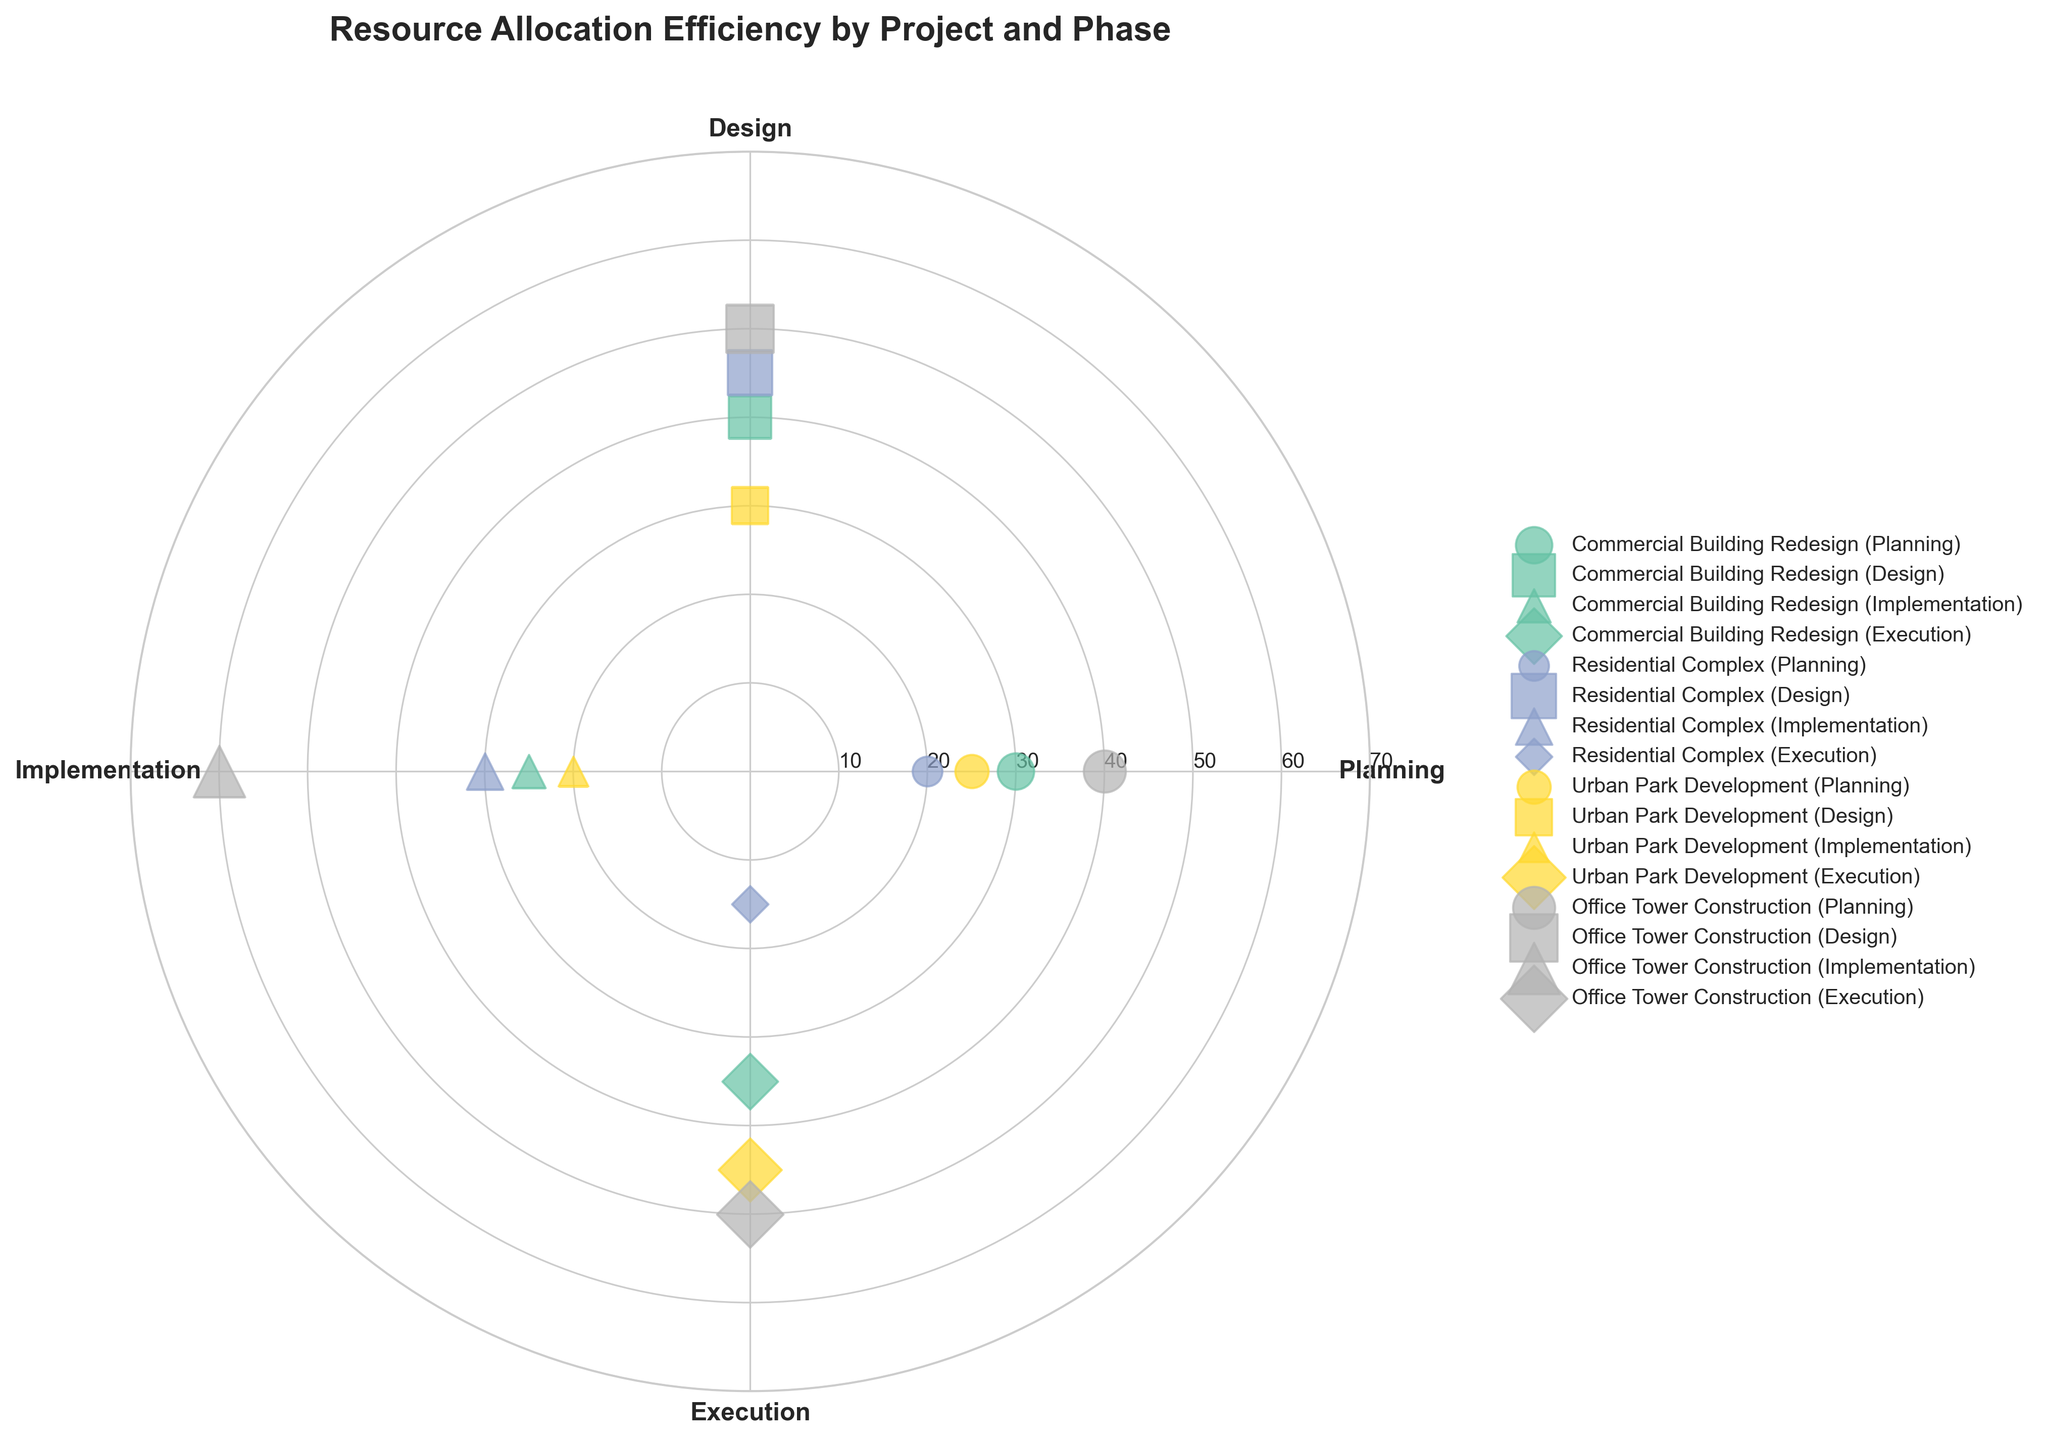what is the title of the figure? The title is located at the top of the figure and is in bold font.
Answer: Resource Allocation Efficiency by Project and Phase Which project has the highest man-hours allocated to the Planning phase? By looking at the points along the Planning axis (0 degrees), the project with the highest man-hours is marked and it corresponds to the highest radius value.
Answer: Office Tower Construction How many different phases are there in the chart? The phases are the labeled categories on the outer circle at the angles 0, 90, 180, and 270 degrees. Count these labels.
Answer: Four Which project has the smallest man-hours allocated to the Execution phase? By looking at the points along the Execution axis (270 degrees), the project with the smallest radius value is the one with the least man-hours.
Answer: Residential Complex What is the total man-hours allocated in the Design phase for all projects? Summing the values of the man-hours corresponding to points along the Design axis (90 degrees). These are 40 (Commercial Building Redesign), 45 (Residential Complex), 30 (Urban Park Development), and 50 (Office Tower Construction). Calculate 40 + 45 + 30 + 50.
Answer: 165 Compare the man-hours allocated to the Planning phase between 'Commercial Building Redesign' and 'Residential Complex'. Which is higher and by how much? Find the points for 'Commercial Building Redesign' and 'Residential Complex' along the Planning axis (0 degrees). Subtract the smaller radius value from the larger one to find the difference. Planning has 30 man-hours for 'Commercial Building Redesign' and 20 for 'Residential Complex'. Calculate 30 - 20.
Answer: Commercial Building Redesign, by 10 man-hours Which project has the most evenly distributed man-hours across all phases? Look for the project whose points are closest together in terms of radii across all phases: Planning, Design, Implementation, and Execution.
Answer: Urban Park Development How many different marker shapes are used in the chart? Review the distinct shapes used for different data points which represent different phases. Count the unique shapes.
Answer: Four What's the average man-hours allocated to the Implementation phase for the 'Office Tower Construction' project? The 'Office Tower Construction' has man-hours for the Implementation phase. Add these values and divide by the number of values. Implementation phase for 'Office Tower Construction' has only 60 man-hours. Since there's only one data point, the average is 60.
Answer: 60 